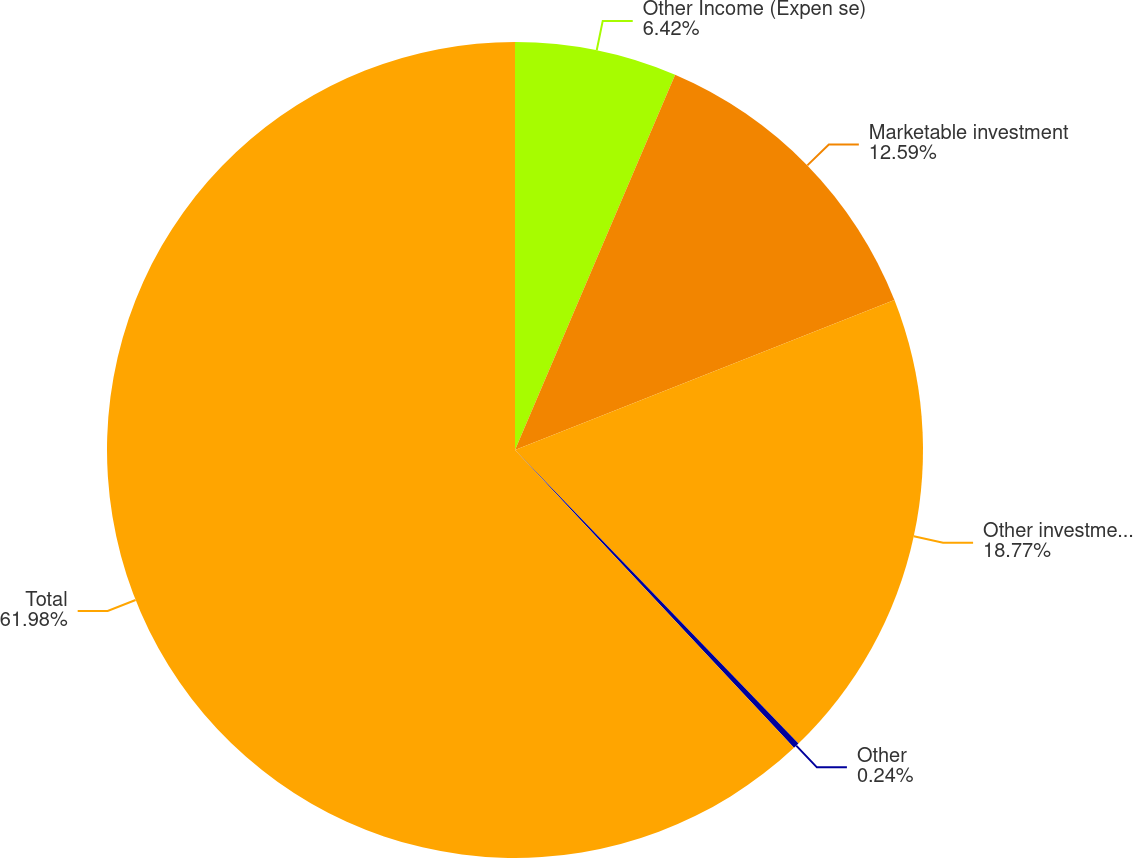Convert chart. <chart><loc_0><loc_0><loc_500><loc_500><pie_chart><fcel>Other Income (Expen se)<fcel>Marketable investment<fcel>Other investment securities -<fcel>Other<fcel>Total<nl><fcel>6.42%<fcel>12.59%<fcel>18.77%<fcel>0.24%<fcel>61.99%<nl></chart> 